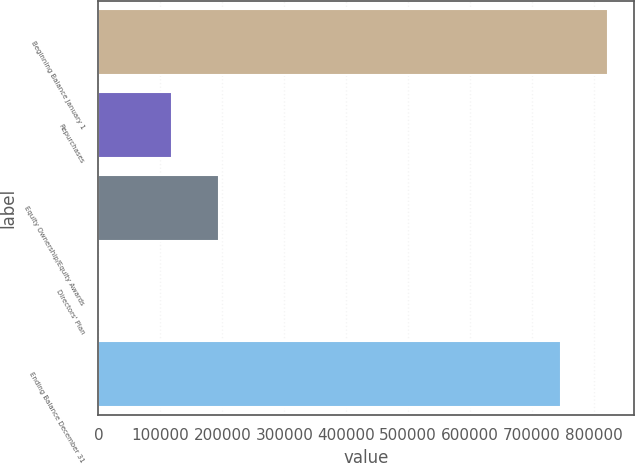Convert chart. <chart><loc_0><loc_0><loc_500><loc_500><bar_chart><fcel>Beginning Balance January 1<fcel>Repurchases<fcel>Equity Ownership/Equity Awards<fcel>Directors' Plan<fcel>Ending Balance December 31<nl><fcel>823189<fcel>118499<fcel>194357<fcel>240<fcel>747331<nl></chart> 